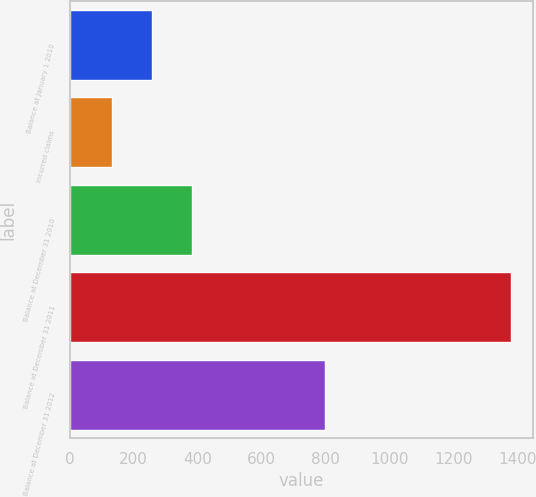Convert chart. <chart><loc_0><loc_0><loc_500><loc_500><bar_chart><fcel>Balance at January 1 2010<fcel>Incurred claims<fcel>Balance at December 31 2010<fcel>Balance at December 31 2011<fcel>Balance at December 31 2012<nl><fcel>257.4<fcel>133<fcel>381.8<fcel>1377<fcel>799<nl></chart> 